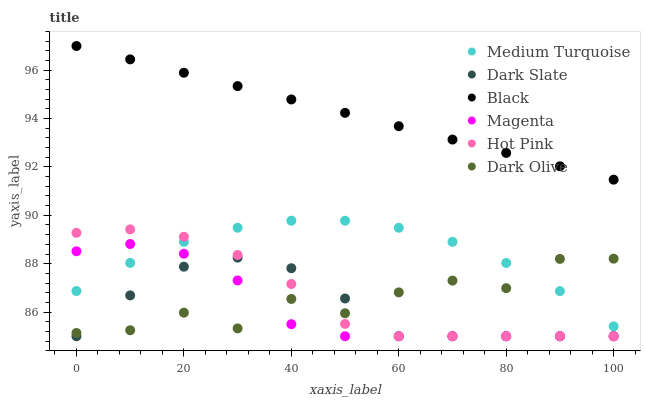Does Magenta have the minimum area under the curve?
Answer yes or no. Yes. Does Black have the maximum area under the curve?
Answer yes or no. Yes. Does Dark Olive have the minimum area under the curve?
Answer yes or no. No. Does Dark Olive have the maximum area under the curve?
Answer yes or no. No. Is Black the smoothest?
Answer yes or no. Yes. Is Dark Olive the roughest?
Answer yes or no. Yes. Is Dark Slate the smoothest?
Answer yes or no. No. Is Dark Slate the roughest?
Answer yes or no. No. Does Hot Pink have the lowest value?
Answer yes or no. Yes. Does Dark Olive have the lowest value?
Answer yes or no. No. Does Black have the highest value?
Answer yes or no. Yes. Does Dark Slate have the highest value?
Answer yes or no. No. Is Medium Turquoise less than Black?
Answer yes or no. Yes. Is Black greater than Dark Slate?
Answer yes or no. Yes. Does Dark Olive intersect Medium Turquoise?
Answer yes or no. Yes. Is Dark Olive less than Medium Turquoise?
Answer yes or no. No. Is Dark Olive greater than Medium Turquoise?
Answer yes or no. No. Does Medium Turquoise intersect Black?
Answer yes or no. No. 